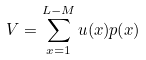<formula> <loc_0><loc_0><loc_500><loc_500>V = \sum _ { x = 1 } ^ { L - M } u ( x ) p ( x )</formula> 